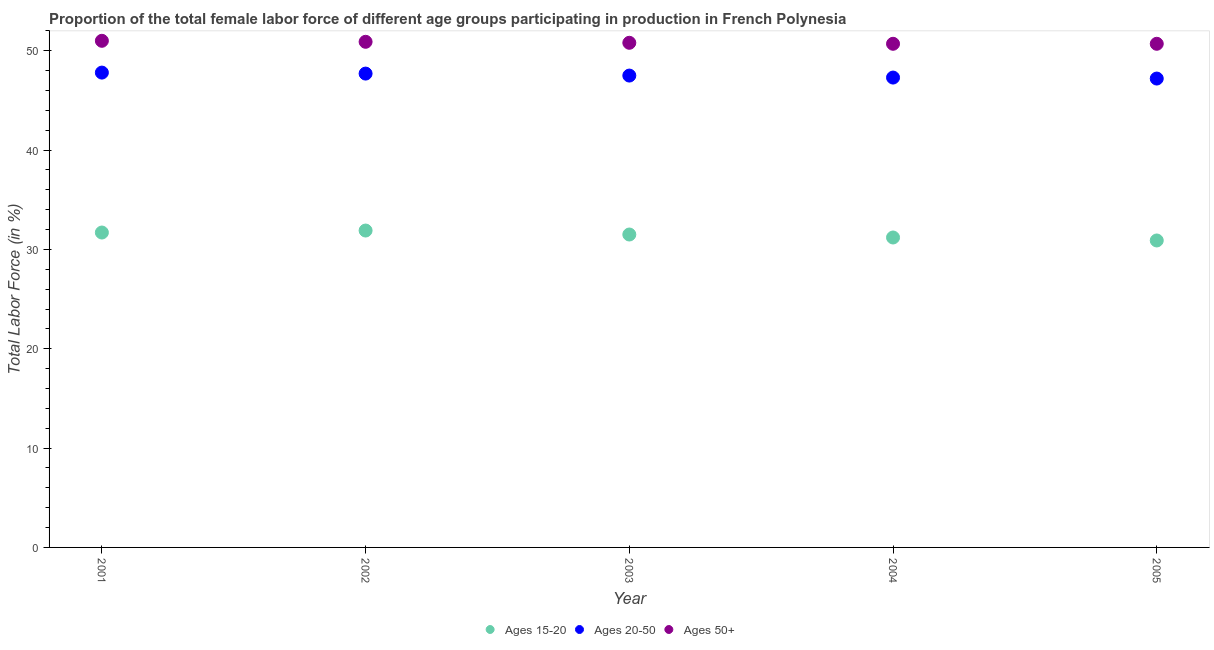How many different coloured dotlines are there?
Provide a short and direct response. 3. Is the number of dotlines equal to the number of legend labels?
Provide a short and direct response. Yes. What is the percentage of female labor force within the age group 15-20 in 2003?
Ensure brevity in your answer.  31.5. Across all years, what is the minimum percentage of female labor force within the age group 15-20?
Give a very brief answer. 30.9. In which year was the percentage of female labor force within the age group 20-50 maximum?
Provide a succinct answer. 2001. What is the total percentage of female labor force within the age group 20-50 in the graph?
Provide a succinct answer. 237.5. What is the difference between the percentage of female labor force above age 50 in 2001 and that in 2005?
Offer a very short reply. 0.3. What is the difference between the percentage of female labor force above age 50 in 2003 and the percentage of female labor force within the age group 20-50 in 2002?
Ensure brevity in your answer.  3.1. What is the average percentage of female labor force within the age group 15-20 per year?
Ensure brevity in your answer.  31.44. In the year 2002, what is the difference between the percentage of female labor force within the age group 20-50 and percentage of female labor force within the age group 15-20?
Your answer should be very brief. 15.8. What is the ratio of the percentage of female labor force within the age group 15-20 in 2003 to that in 2004?
Make the answer very short. 1.01. Is the percentage of female labor force within the age group 15-20 in 2003 less than that in 2004?
Provide a succinct answer. No. What is the difference between the highest and the second highest percentage of female labor force within the age group 20-50?
Ensure brevity in your answer.  0.1. What is the difference between the highest and the lowest percentage of female labor force within the age group 15-20?
Provide a short and direct response. 1. In how many years, is the percentage of female labor force within the age group 15-20 greater than the average percentage of female labor force within the age group 15-20 taken over all years?
Give a very brief answer. 3. Is the sum of the percentage of female labor force within the age group 15-20 in 2001 and 2005 greater than the maximum percentage of female labor force within the age group 20-50 across all years?
Offer a terse response. Yes. Is it the case that in every year, the sum of the percentage of female labor force within the age group 15-20 and percentage of female labor force within the age group 20-50 is greater than the percentage of female labor force above age 50?
Offer a very short reply. Yes. Does the percentage of female labor force within the age group 20-50 monotonically increase over the years?
Your answer should be very brief. No. How many dotlines are there?
Keep it short and to the point. 3. How many years are there in the graph?
Your response must be concise. 5. What is the difference between two consecutive major ticks on the Y-axis?
Give a very brief answer. 10. Does the graph contain any zero values?
Give a very brief answer. No. Does the graph contain grids?
Offer a very short reply. No. Where does the legend appear in the graph?
Ensure brevity in your answer.  Bottom center. How many legend labels are there?
Your response must be concise. 3. How are the legend labels stacked?
Ensure brevity in your answer.  Horizontal. What is the title of the graph?
Ensure brevity in your answer.  Proportion of the total female labor force of different age groups participating in production in French Polynesia. Does "Consumption Tax" appear as one of the legend labels in the graph?
Provide a succinct answer. No. What is the Total Labor Force (in %) in Ages 15-20 in 2001?
Your response must be concise. 31.7. What is the Total Labor Force (in %) of Ages 20-50 in 2001?
Ensure brevity in your answer.  47.8. What is the Total Labor Force (in %) of Ages 15-20 in 2002?
Your answer should be very brief. 31.9. What is the Total Labor Force (in %) of Ages 20-50 in 2002?
Make the answer very short. 47.7. What is the Total Labor Force (in %) of Ages 50+ in 2002?
Give a very brief answer. 50.9. What is the Total Labor Force (in %) in Ages 15-20 in 2003?
Your answer should be compact. 31.5. What is the Total Labor Force (in %) of Ages 20-50 in 2003?
Your answer should be compact. 47.5. What is the Total Labor Force (in %) of Ages 50+ in 2003?
Keep it short and to the point. 50.8. What is the Total Labor Force (in %) in Ages 15-20 in 2004?
Provide a short and direct response. 31.2. What is the Total Labor Force (in %) of Ages 20-50 in 2004?
Your answer should be very brief. 47.3. What is the Total Labor Force (in %) in Ages 50+ in 2004?
Provide a succinct answer. 50.7. What is the Total Labor Force (in %) in Ages 15-20 in 2005?
Your response must be concise. 30.9. What is the Total Labor Force (in %) of Ages 20-50 in 2005?
Ensure brevity in your answer.  47.2. What is the Total Labor Force (in %) of Ages 50+ in 2005?
Provide a succinct answer. 50.7. Across all years, what is the maximum Total Labor Force (in %) of Ages 15-20?
Provide a short and direct response. 31.9. Across all years, what is the maximum Total Labor Force (in %) in Ages 20-50?
Ensure brevity in your answer.  47.8. Across all years, what is the maximum Total Labor Force (in %) in Ages 50+?
Keep it short and to the point. 51. Across all years, what is the minimum Total Labor Force (in %) of Ages 15-20?
Provide a succinct answer. 30.9. Across all years, what is the minimum Total Labor Force (in %) in Ages 20-50?
Your response must be concise. 47.2. Across all years, what is the minimum Total Labor Force (in %) in Ages 50+?
Keep it short and to the point. 50.7. What is the total Total Labor Force (in %) in Ages 15-20 in the graph?
Provide a succinct answer. 157.2. What is the total Total Labor Force (in %) in Ages 20-50 in the graph?
Provide a succinct answer. 237.5. What is the total Total Labor Force (in %) in Ages 50+ in the graph?
Offer a terse response. 254.1. What is the difference between the Total Labor Force (in %) in Ages 15-20 in 2001 and that in 2002?
Offer a very short reply. -0.2. What is the difference between the Total Labor Force (in %) in Ages 50+ in 2001 and that in 2002?
Your answer should be compact. 0.1. What is the difference between the Total Labor Force (in %) of Ages 15-20 in 2001 and that in 2003?
Your answer should be compact. 0.2. What is the difference between the Total Labor Force (in %) of Ages 20-50 in 2001 and that in 2004?
Offer a terse response. 0.5. What is the difference between the Total Labor Force (in %) of Ages 50+ in 2001 and that in 2004?
Your response must be concise. 0.3. What is the difference between the Total Labor Force (in %) in Ages 15-20 in 2001 and that in 2005?
Make the answer very short. 0.8. What is the difference between the Total Labor Force (in %) of Ages 20-50 in 2001 and that in 2005?
Provide a short and direct response. 0.6. What is the difference between the Total Labor Force (in %) in Ages 50+ in 2001 and that in 2005?
Your answer should be very brief. 0.3. What is the difference between the Total Labor Force (in %) of Ages 20-50 in 2002 and that in 2003?
Ensure brevity in your answer.  0.2. What is the difference between the Total Labor Force (in %) of Ages 15-20 in 2002 and that in 2004?
Your answer should be very brief. 0.7. What is the difference between the Total Labor Force (in %) of Ages 20-50 in 2002 and that in 2004?
Your answer should be compact. 0.4. What is the difference between the Total Labor Force (in %) of Ages 20-50 in 2003 and that in 2004?
Your response must be concise. 0.2. What is the difference between the Total Labor Force (in %) in Ages 50+ in 2003 and that in 2004?
Give a very brief answer. 0.1. What is the difference between the Total Labor Force (in %) of Ages 50+ in 2003 and that in 2005?
Offer a terse response. 0.1. What is the difference between the Total Labor Force (in %) in Ages 15-20 in 2004 and that in 2005?
Ensure brevity in your answer.  0.3. What is the difference between the Total Labor Force (in %) of Ages 15-20 in 2001 and the Total Labor Force (in %) of Ages 50+ in 2002?
Offer a terse response. -19.2. What is the difference between the Total Labor Force (in %) of Ages 20-50 in 2001 and the Total Labor Force (in %) of Ages 50+ in 2002?
Give a very brief answer. -3.1. What is the difference between the Total Labor Force (in %) of Ages 15-20 in 2001 and the Total Labor Force (in %) of Ages 20-50 in 2003?
Ensure brevity in your answer.  -15.8. What is the difference between the Total Labor Force (in %) of Ages 15-20 in 2001 and the Total Labor Force (in %) of Ages 50+ in 2003?
Your response must be concise. -19.1. What is the difference between the Total Labor Force (in %) in Ages 15-20 in 2001 and the Total Labor Force (in %) in Ages 20-50 in 2004?
Your response must be concise. -15.6. What is the difference between the Total Labor Force (in %) of Ages 15-20 in 2001 and the Total Labor Force (in %) of Ages 50+ in 2004?
Your answer should be very brief. -19. What is the difference between the Total Labor Force (in %) of Ages 20-50 in 2001 and the Total Labor Force (in %) of Ages 50+ in 2004?
Your answer should be very brief. -2.9. What is the difference between the Total Labor Force (in %) of Ages 15-20 in 2001 and the Total Labor Force (in %) of Ages 20-50 in 2005?
Offer a very short reply. -15.5. What is the difference between the Total Labor Force (in %) of Ages 15-20 in 2001 and the Total Labor Force (in %) of Ages 50+ in 2005?
Your answer should be very brief. -19. What is the difference between the Total Labor Force (in %) of Ages 15-20 in 2002 and the Total Labor Force (in %) of Ages 20-50 in 2003?
Your answer should be compact. -15.6. What is the difference between the Total Labor Force (in %) in Ages 15-20 in 2002 and the Total Labor Force (in %) in Ages 50+ in 2003?
Offer a very short reply. -18.9. What is the difference between the Total Labor Force (in %) of Ages 15-20 in 2002 and the Total Labor Force (in %) of Ages 20-50 in 2004?
Your answer should be compact. -15.4. What is the difference between the Total Labor Force (in %) of Ages 15-20 in 2002 and the Total Labor Force (in %) of Ages 50+ in 2004?
Your answer should be very brief. -18.8. What is the difference between the Total Labor Force (in %) of Ages 20-50 in 2002 and the Total Labor Force (in %) of Ages 50+ in 2004?
Offer a terse response. -3. What is the difference between the Total Labor Force (in %) of Ages 15-20 in 2002 and the Total Labor Force (in %) of Ages 20-50 in 2005?
Give a very brief answer. -15.3. What is the difference between the Total Labor Force (in %) of Ages 15-20 in 2002 and the Total Labor Force (in %) of Ages 50+ in 2005?
Ensure brevity in your answer.  -18.8. What is the difference between the Total Labor Force (in %) of Ages 15-20 in 2003 and the Total Labor Force (in %) of Ages 20-50 in 2004?
Offer a very short reply. -15.8. What is the difference between the Total Labor Force (in %) in Ages 15-20 in 2003 and the Total Labor Force (in %) in Ages 50+ in 2004?
Offer a very short reply. -19.2. What is the difference between the Total Labor Force (in %) of Ages 15-20 in 2003 and the Total Labor Force (in %) of Ages 20-50 in 2005?
Give a very brief answer. -15.7. What is the difference between the Total Labor Force (in %) of Ages 15-20 in 2003 and the Total Labor Force (in %) of Ages 50+ in 2005?
Provide a short and direct response. -19.2. What is the difference between the Total Labor Force (in %) in Ages 20-50 in 2003 and the Total Labor Force (in %) in Ages 50+ in 2005?
Give a very brief answer. -3.2. What is the difference between the Total Labor Force (in %) of Ages 15-20 in 2004 and the Total Labor Force (in %) of Ages 20-50 in 2005?
Ensure brevity in your answer.  -16. What is the difference between the Total Labor Force (in %) of Ages 15-20 in 2004 and the Total Labor Force (in %) of Ages 50+ in 2005?
Provide a succinct answer. -19.5. What is the average Total Labor Force (in %) of Ages 15-20 per year?
Provide a succinct answer. 31.44. What is the average Total Labor Force (in %) in Ages 20-50 per year?
Offer a terse response. 47.5. What is the average Total Labor Force (in %) in Ages 50+ per year?
Provide a short and direct response. 50.82. In the year 2001, what is the difference between the Total Labor Force (in %) in Ages 15-20 and Total Labor Force (in %) in Ages 20-50?
Ensure brevity in your answer.  -16.1. In the year 2001, what is the difference between the Total Labor Force (in %) in Ages 15-20 and Total Labor Force (in %) in Ages 50+?
Make the answer very short. -19.3. In the year 2001, what is the difference between the Total Labor Force (in %) of Ages 20-50 and Total Labor Force (in %) of Ages 50+?
Provide a short and direct response. -3.2. In the year 2002, what is the difference between the Total Labor Force (in %) in Ages 15-20 and Total Labor Force (in %) in Ages 20-50?
Your answer should be very brief. -15.8. In the year 2003, what is the difference between the Total Labor Force (in %) of Ages 15-20 and Total Labor Force (in %) of Ages 20-50?
Your response must be concise. -16. In the year 2003, what is the difference between the Total Labor Force (in %) of Ages 15-20 and Total Labor Force (in %) of Ages 50+?
Offer a terse response. -19.3. In the year 2003, what is the difference between the Total Labor Force (in %) in Ages 20-50 and Total Labor Force (in %) in Ages 50+?
Your response must be concise. -3.3. In the year 2004, what is the difference between the Total Labor Force (in %) in Ages 15-20 and Total Labor Force (in %) in Ages 20-50?
Give a very brief answer. -16.1. In the year 2004, what is the difference between the Total Labor Force (in %) in Ages 15-20 and Total Labor Force (in %) in Ages 50+?
Your response must be concise. -19.5. In the year 2005, what is the difference between the Total Labor Force (in %) in Ages 15-20 and Total Labor Force (in %) in Ages 20-50?
Ensure brevity in your answer.  -16.3. In the year 2005, what is the difference between the Total Labor Force (in %) in Ages 15-20 and Total Labor Force (in %) in Ages 50+?
Keep it short and to the point. -19.8. What is the ratio of the Total Labor Force (in %) in Ages 50+ in 2001 to that in 2003?
Provide a short and direct response. 1. What is the ratio of the Total Labor Force (in %) of Ages 20-50 in 2001 to that in 2004?
Your answer should be compact. 1.01. What is the ratio of the Total Labor Force (in %) in Ages 50+ in 2001 to that in 2004?
Make the answer very short. 1.01. What is the ratio of the Total Labor Force (in %) of Ages 15-20 in 2001 to that in 2005?
Keep it short and to the point. 1.03. What is the ratio of the Total Labor Force (in %) of Ages 20-50 in 2001 to that in 2005?
Offer a terse response. 1.01. What is the ratio of the Total Labor Force (in %) in Ages 50+ in 2001 to that in 2005?
Offer a very short reply. 1.01. What is the ratio of the Total Labor Force (in %) in Ages 15-20 in 2002 to that in 2003?
Offer a very short reply. 1.01. What is the ratio of the Total Labor Force (in %) in Ages 20-50 in 2002 to that in 2003?
Offer a terse response. 1. What is the ratio of the Total Labor Force (in %) of Ages 50+ in 2002 to that in 2003?
Ensure brevity in your answer.  1. What is the ratio of the Total Labor Force (in %) of Ages 15-20 in 2002 to that in 2004?
Provide a succinct answer. 1.02. What is the ratio of the Total Labor Force (in %) in Ages 20-50 in 2002 to that in 2004?
Your answer should be compact. 1.01. What is the ratio of the Total Labor Force (in %) in Ages 15-20 in 2002 to that in 2005?
Provide a short and direct response. 1.03. What is the ratio of the Total Labor Force (in %) in Ages 20-50 in 2002 to that in 2005?
Offer a very short reply. 1.01. What is the ratio of the Total Labor Force (in %) of Ages 15-20 in 2003 to that in 2004?
Give a very brief answer. 1.01. What is the ratio of the Total Labor Force (in %) in Ages 15-20 in 2003 to that in 2005?
Ensure brevity in your answer.  1.02. What is the ratio of the Total Labor Force (in %) in Ages 20-50 in 2003 to that in 2005?
Your answer should be compact. 1.01. What is the ratio of the Total Labor Force (in %) of Ages 50+ in 2003 to that in 2005?
Your answer should be very brief. 1. What is the ratio of the Total Labor Force (in %) of Ages 15-20 in 2004 to that in 2005?
Your answer should be compact. 1.01. What is the ratio of the Total Labor Force (in %) in Ages 20-50 in 2004 to that in 2005?
Offer a very short reply. 1. What is the ratio of the Total Labor Force (in %) in Ages 50+ in 2004 to that in 2005?
Ensure brevity in your answer.  1. What is the difference between the highest and the second highest Total Labor Force (in %) of Ages 15-20?
Provide a succinct answer. 0.2. What is the difference between the highest and the second highest Total Labor Force (in %) in Ages 50+?
Give a very brief answer. 0.1. What is the difference between the highest and the lowest Total Labor Force (in %) of Ages 20-50?
Give a very brief answer. 0.6. What is the difference between the highest and the lowest Total Labor Force (in %) in Ages 50+?
Give a very brief answer. 0.3. 